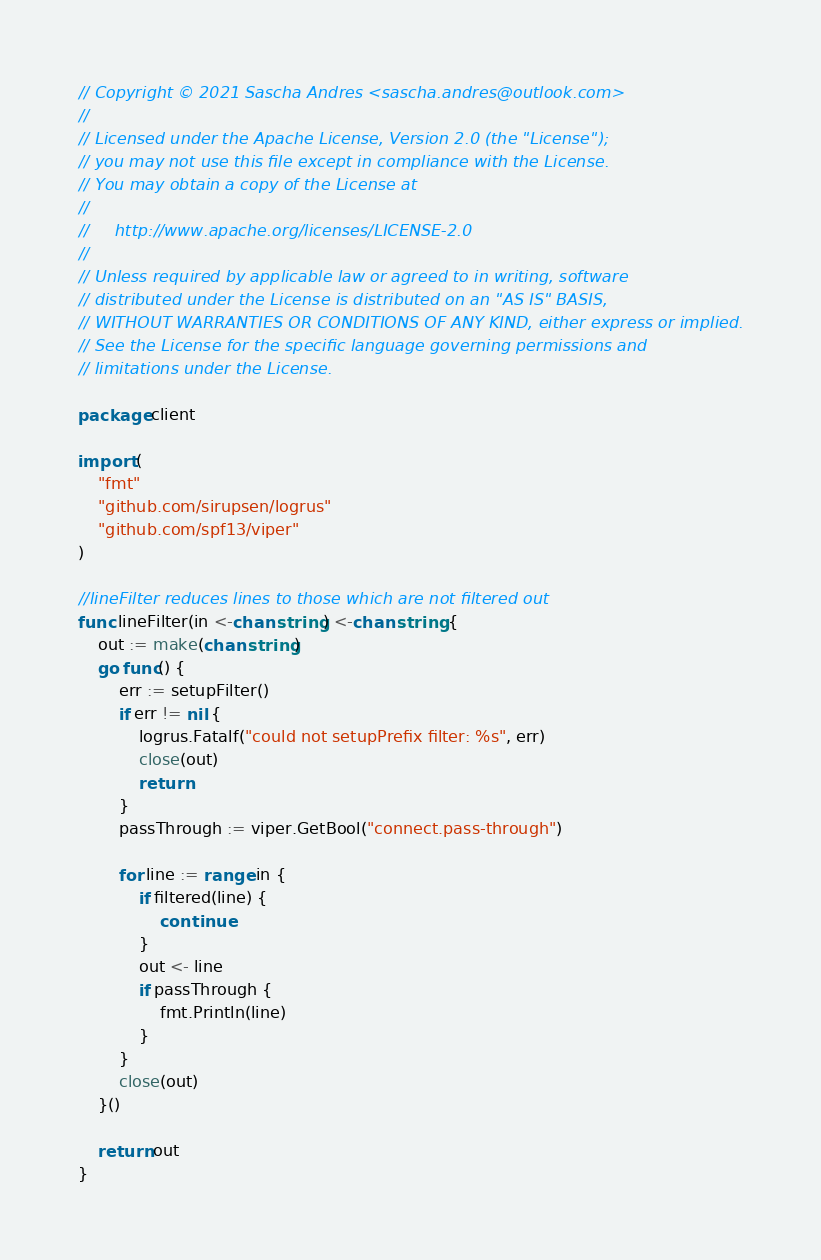<code> <loc_0><loc_0><loc_500><loc_500><_Go_>// Copyright © 2021 Sascha Andres <sascha.andres@outlook.com>
//
// Licensed under the Apache License, Version 2.0 (the "License");
// you may not use this file except in compliance with the License.
// You may obtain a copy of the License at
//
//     http://www.apache.org/licenses/LICENSE-2.0
//
// Unless required by applicable law or agreed to in writing, software
// distributed under the License is distributed on an "AS IS" BASIS,
// WITHOUT WARRANTIES OR CONDITIONS OF ANY KIND, either express or implied.
// See the License for the specific language governing permissions and
// limitations under the License.

package client

import (
	"fmt"
	"github.com/sirupsen/logrus"
	"github.com/spf13/viper"
)

//lineFilter reduces lines to those which are not filtered out
func lineFilter(in <-chan string) <-chan string {
	out := make(chan string)
	go func() {
		err := setupFilter()
		if err != nil {
			logrus.Fatalf("could not setupPrefix filter: %s", err)
			close(out)
			return
		}
		passThrough := viper.GetBool("connect.pass-through")

		for line := range in {
			if filtered(line) {
				continue
			}
			out <- line
			if passThrough {
				fmt.Println(line)
			}
		}
		close(out)
	}()

	return out
}

</code> 